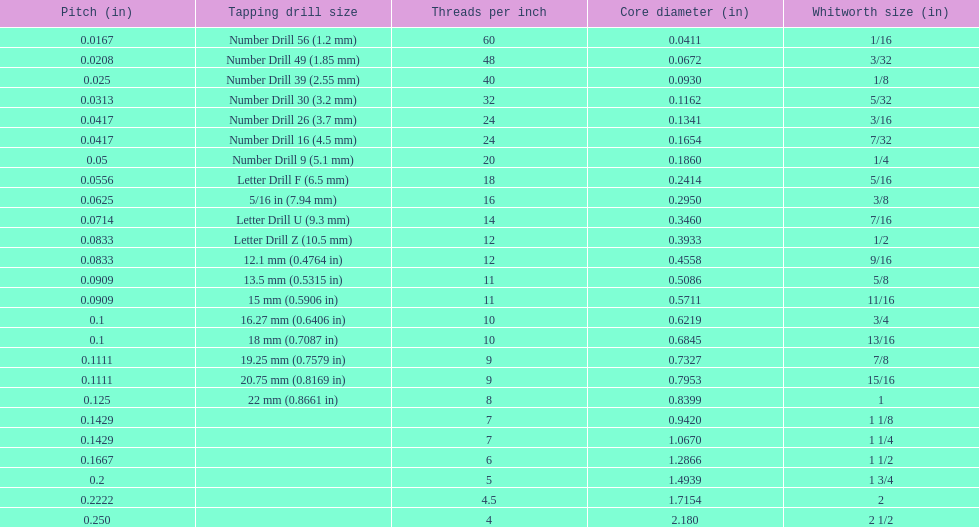What is the least core diameter (in)? 0.0411. 